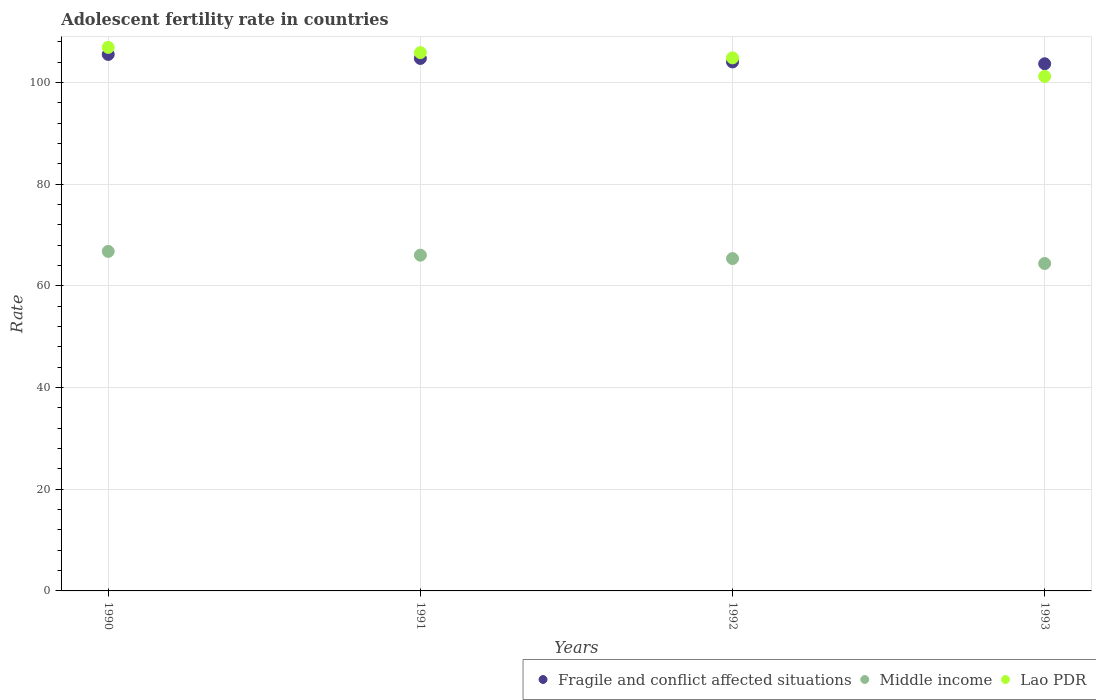How many different coloured dotlines are there?
Keep it short and to the point. 3. What is the adolescent fertility rate in Fragile and conflict affected situations in 1990?
Provide a succinct answer. 105.54. Across all years, what is the maximum adolescent fertility rate in Middle income?
Offer a terse response. 66.79. Across all years, what is the minimum adolescent fertility rate in Fragile and conflict affected situations?
Give a very brief answer. 103.7. In which year was the adolescent fertility rate in Lao PDR maximum?
Your answer should be very brief. 1990. What is the total adolescent fertility rate in Middle income in the graph?
Your answer should be compact. 262.63. What is the difference between the adolescent fertility rate in Fragile and conflict affected situations in 1991 and that in 1993?
Your answer should be very brief. 1.05. What is the difference between the adolescent fertility rate in Middle income in 1993 and the adolescent fertility rate in Fragile and conflict affected situations in 1990?
Your response must be concise. -41.13. What is the average adolescent fertility rate in Fragile and conflict affected situations per year?
Give a very brief answer. 104.51. In the year 1991, what is the difference between the adolescent fertility rate in Fragile and conflict affected situations and adolescent fertility rate in Middle income?
Ensure brevity in your answer.  38.7. In how many years, is the adolescent fertility rate in Middle income greater than 4?
Your answer should be very brief. 4. What is the ratio of the adolescent fertility rate in Fragile and conflict affected situations in 1991 to that in 1992?
Your response must be concise. 1.01. Is the adolescent fertility rate in Lao PDR in 1990 less than that in 1992?
Make the answer very short. No. What is the difference between the highest and the second highest adolescent fertility rate in Fragile and conflict affected situations?
Your answer should be compact. 0.79. What is the difference between the highest and the lowest adolescent fertility rate in Fragile and conflict affected situations?
Provide a short and direct response. 1.84. In how many years, is the adolescent fertility rate in Middle income greater than the average adolescent fertility rate in Middle income taken over all years?
Provide a succinct answer. 2. Is the sum of the adolescent fertility rate in Lao PDR in 1990 and 1993 greater than the maximum adolescent fertility rate in Middle income across all years?
Offer a very short reply. Yes. Is it the case that in every year, the sum of the adolescent fertility rate in Middle income and adolescent fertility rate in Fragile and conflict affected situations  is greater than the adolescent fertility rate in Lao PDR?
Offer a very short reply. Yes. Is the adolescent fertility rate in Middle income strictly greater than the adolescent fertility rate in Lao PDR over the years?
Your answer should be very brief. No. How many years are there in the graph?
Provide a succinct answer. 4. What is the difference between two consecutive major ticks on the Y-axis?
Provide a short and direct response. 20. Are the values on the major ticks of Y-axis written in scientific E-notation?
Provide a short and direct response. No. Does the graph contain any zero values?
Ensure brevity in your answer.  No. Does the graph contain grids?
Your answer should be very brief. Yes. What is the title of the graph?
Offer a very short reply. Adolescent fertility rate in countries. Does "Cambodia" appear as one of the legend labels in the graph?
Make the answer very short. No. What is the label or title of the Y-axis?
Your answer should be compact. Rate. What is the Rate in Fragile and conflict affected situations in 1990?
Keep it short and to the point. 105.54. What is the Rate in Middle income in 1990?
Make the answer very short. 66.79. What is the Rate in Lao PDR in 1990?
Keep it short and to the point. 106.93. What is the Rate of Fragile and conflict affected situations in 1991?
Your answer should be compact. 104.75. What is the Rate of Middle income in 1991?
Offer a terse response. 66.05. What is the Rate in Lao PDR in 1991?
Provide a succinct answer. 105.9. What is the Rate in Fragile and conflict affected situations in 1992?
Make the answer very short. 104.06. What is the Rate in Middle income in 1992?
Give a very brief answer. 65.38. What is the Rate of Lao PDR in 1992?
Your answer should be very brief. 104.86. What is the Rate of Fragile and conflict affected situations in 1993?
Give a very brief answer. 103.7. What is the Rate in Middle income in 1993?
Provide a succinct answer. 64.41. What is the Rate of Lao PDR in 1993?
Your response must be concise. 101.22. Across all years, what is the maximum Rate of Fragile and conflict affected situations?
Your answer should be very brief. 105.54. Across all years, what is the maximum Rate of Middle income?
Provide a short and direct response. 66.79. Across all years, what is the maximum Rate of Lao PDR?
Your answer should be very brief. 106.93. Across all years, what is the minimum Rate of Fragile and conflict affected situations?
Provide a short and direct response. 103.7. Across all years, what is the minimum Rate of Middle income?
Your answer should be compact. 64.41. Across all years, what is the minimum Rate in Lao PDR?
Your response must be concise. 101.22. What is the total Rate of Fragile and conflict affected situations in the graph?
Offer a very short reply. 418.05. What is the total Rate of Middle income in the graph?
Provide a short and direct response. 262.63. What is the total Rate in Lao PDR in the graph?
Give a very brief answer. 418.9. What is the difference between the Rate in Fragile and conflict affected situations in 1990 and that in 1991?
Your response must be concise. 0.79. What is the difference between the Rate of Middle income in 1990 and that in 1991?
Give a very brief answer. 0.74. What is the difference between the Rate of Lao PDR in 1990 and that in 1991?
Your answer should be very brief. 1.03. What is the difference between the Rate of Fragile and conflict affected situations in 1990 and that in 1992?
Provide a short and direct response. 1.48. What is the difference between the Rate of Middle income in 1990 and that in 1992?
Give a very brief answer. 1.41. What is the difference between the Rate in Lao PDR in 1990 and that in 1992?
Ensure brevity in your answer.  2.06. What is the difference between the Rate of Fragile and conflict affected situations in 1990 and that in 1993?
Make the answer very short. 1.84. What is the difference between the Rate of Middle income in 1990 and that in 1993?
Offer a terse response. 2.38. What is the difference between the Rate in Lao PDR in 1990 and that in 1993?
Keep it short and to the point. 5.71. What is the difference between the Rate of Fragile and conflict affected situations in 1991 and that in 1992?
Provide a succinct answer. 0.69. What is the difference between the Rate in Middle income in 1991 and that in 1992?
Give a very brief answer. 0.67. What is the difference between the Rate of Lao PDR in 1991 and that in 1992?
Your answer should be compact. 1.03. What is the difference between the Rate of Fragile and conflict affected situations in 1991 and that in 1993?
Offer a very short reply. 1.05. What is the difference between the Rate of Middle income in 1991 and that in 1993?
Ensure brevity in your answer.  1.64. What is the difference between the Rate of Lao PDR in 1991 and that in 1993?
Provide a succinct answer. 4.68. What is the difference between the Rate in Fragile and conflict affected situations in 1992 and that in 1993?
Keep it short and to the point. 0.36. What is the difference between the Rate in Middle income in 1992 and that in 1993?
Provide a succinct answer. 0.97. What is the difference between the Rate in Lao PDR in 1992 and that in 1993?
Offer a very short reply. 3.65. What is the difference between the Rate of Fragile and conflict affected situations in 1990 and the Rate of Middle income in 1991?
Provide a short and direct response. 39.49. What is the difference between the Rate in Fragile and conflict affected situations in 1990 and the Rate in Lao PDR in 1991?
Your response must be concise. -0.36. What is the difference between the Rate of Middle income in 1990 and the Rate of Lao PDR in 1991?
Ensure brevity in your answer.  -39.11. What is the difference between the Rate of Fragile and conflict affected situations in 1990 and the Rate of Middle income in 1992?
Offer a very short reply. 40.16. What is the difference between the Rate in Fragile and conflict affected situations in 1990 and the Rate in Lao PDR in 1992?
Offer a terse response. 0.68. What is the difference between the Rate of Middle income in 1990 and the Rate of Lao PDR in 1992?
Make the answer very short. -38.07. What is the difference between the Rate of Fragile and conflict affected situations in 1990 and the Rate of Middle income in 1993?
Offer a terse response. 41.13. What is the difference between the Rate in Fragile and conflict affected situations in 1990 and the Rate in Lao PDR in 1993?
Provide a succinct answer. 4.32. What is the difference between the Rate in Middle income in 1990 and the Rate in Lao PDR in 1993?
Keep it short and to the point. -34.43. What is the difference between the Rate in Fragile and conflict affected situations in 1991 and the Rate in Middle income in 1992?
Keep it short and to the point. 39.37. What is the difference between the Rate of Fragile and conflict affected situations in 1991 and the Rate of Lao PDR in 1992?
Provide a succinct answer. -0.11. What is the difference between the Rate in Middle income in 1991 and the Rate in Lao PDR in 1992?
Your answer should be compact. -38.81. What is the difference between the Rate in Fragile and conflict affected situations in 1991 and the Rate in Middle income in 1993?
Provide a succinct answer. 40.34. What is the difference between the Rate in Fragile and conflict affected situations in 1991 and the Rate in Lao PDR in 1993?
Your answer should be very brief. 3.53. What is the difference between the Rate in Middle income in 1991 and the Rate in Lao PDR in 1993?
Ensure brevity in your answer.  -35.17. What is the difference between the Rate in Fragile and conflict affected situations in 1992 and the Rate in Middle income in 1993?
Provide a short and direct response. 39.65. What is the difference between the Rate in Fragile and conflict affected situations in 1992 and the Rate in Lao PDR in 1993?
Your answer should be very brief. 2.85. What is the difference between the Rate in Middle income in 1992 and the Rate in Lao PDR in 1993?
Provide a short and direct response. -35.84. What is the average Rate in Fragile and conflict affected situations per year?
Offer a terse response. 104.51. What is the average Rate in Middle income per year?
Make the answer very short. 65.66. What is the average Rate of Lao PDR per year?
Ensure brevity in your answer.  104.73. In the year 1990, what is the difference between the Rate of Fragile and conflict affected situations and Rate of Middle income?
Ensure brevity in your answer.  38.75. In the year 1990, what is the difference between the Rate in Fragile and conflict affected situations and Rate in Lao PDR?
Keep it short and to the point. -1.39. In the year 1990, what is the difference between the Rate in Middle income and Rate in Lao PDR?
Provide a short and direct response. -40.14. In the year 1991, what is the difference between the Rate in Fragile and conflict affected situations and Rate in Middle income?
Provide a short and direct response. 38.7. In the year 1991, what is the difference between the Rate in Fragile and conflict affected situations and Rate in Lao PDR?
Ensure brevity in your answer.  -1.15. In the year 1991, what is the difference between the Rate in Middle income and Rate in Lao PDR?
Ensure brevity in your answer.  -39.84. In the year 1992, what is the difference between the Rate in Fragile and conflict affected situations and Rate in Middle income?
Provide a succinct answer. 38.68. In the year 1992, what is the difference between the Rate of Fragile and conflict affected situations and Rate of Lao PDR?
Keep it short and to the point. -0.8. In the year 1992, what is the difference between the Rate in Middle income and Rate in Lao PDR?
Provide a short and direct response. -39.48. In the year 1993, what is the difference between the Rate of Fragile and conflict affected situations and Rate of Middle income?
Offer a terse response. 39.29. In the year 1993, what is the difference between the Rate in Fragile and conflict affected situations and Rate in Lao PDR?
Offer a terse response. 2.49. In the year 1993, what is the difference between the Rate in Middle income and Rate in Lao PDR?
Your answer should be very brief. -36.8. What is the ratio of the Rate of Fragile and conflict affected situations in 1990 to that in 1991?
Your answer should be compact. 1.01. What is the ratio of the Rate of Middle income in 1990 to that in 1991?
Your answer should be compact. 1.01. What is the ratio of the Rate in Lao PDR in 1990 to that in 1991?
Provide a succinct answer. 1.01. What is the ratio of the Rate in Fragile and conflict affected situations in 1990 to that in 1992?
Offer a very short reply. 1.01. What is the ratio of the Rate of Middle income in 1990 to that in 1992?
Provide a short and direct response. 1.02. What is the ratio of the Rate of Lao PDR in 1990 to that in 1992?
Provide a short and direct response. 1.02. What is the ratio of the Rate in Fragile and conflict affected situations in 1990 to that in 1993?
Give a very brief answer. 1.02. What is the ratio of the Rate of Middle income in 1990 to that in 1993?
Your answer should be very brief. 1.04. What is the ratio of the Rate in Lao PDR in 1990 to that in 1993?
Give a very brief answer. 1.06. What is the ratio of the Rate of Fragile and conflict affected situations in 1991 to that in 1992?
Keep it short and to the point. 1.01. What is the ratio of the Rate of Middle income in 1991 to that in 1992?
Make the answer very short. 1.01. What is the ratio of the Rate in Lao PDR in 1991 to that in 1992?
Your answer should be very brief. 1.01. What is the ratio of the Rate in Fragile and conflict affected situations in 1991 to that in 1993?
Your response must be concise. 1.01. What is the ratio of the Rate in Middle income in 1991 to that in 1993?
Provide a succinct answer. 1.03. What is the ratio of the Rate in Lao PDR in 1991 to that in 1993?
Your answer should be very brief. 1.05. What is the ratio of the Rate in Middle income in 1992 to that in 1993?
Give a very brief answer. 1.01. What is the ratio of the Rate of Lao PDR in 1992 to that in 1993?
Ensure brevity in your answer.  1.04. What is the difference between the highest and the second highest Rate in Fragile and conflict affected situations?
Your answer should be very brief. 0.79. What is the difference between the highest and the second highest Rate of Middle income?
Offer a terse response. 0.74. What is the difference between the highest and the second highest Rate in Lao PDR?
Provide a succinct answer. 1.03. What is the difference between the highest and the lowest Rate of Fragile and conflict affected situations?
Keep it short and to the point. 1.84. What is the difference between the highest and the lowest Rate in Middle income?
Provide a succinct answer. 2.38. What is the difference between the highest and the lowest Rate in Lao PDR?
Provide a succinct answer. 5.71. 